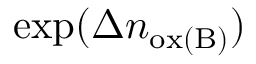<formula> <loc_0><loc_0><loc_500><loc_500>\exp ( \Delta n _ { o x ( B ) } )</formula> 